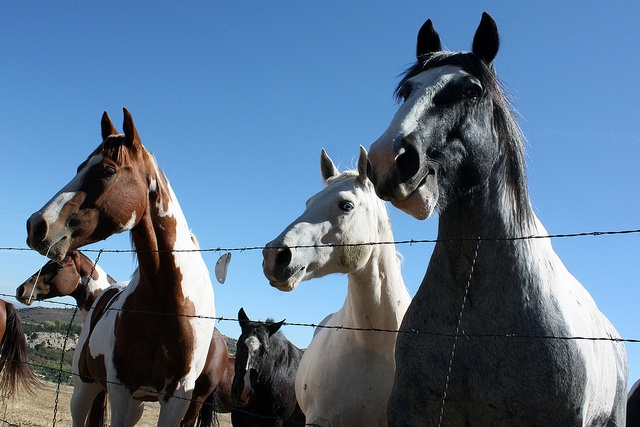Describe the objects in this image and their specific colors. I can see horse in gray, black, white, and darkgray tones, horse in gray, black, white, and maroon tones, horse in gray, black, lightgray, and darkgray tones, horse in gray, black, and darkgray tones, and horse in gray, black, and maroon tones in this image. 